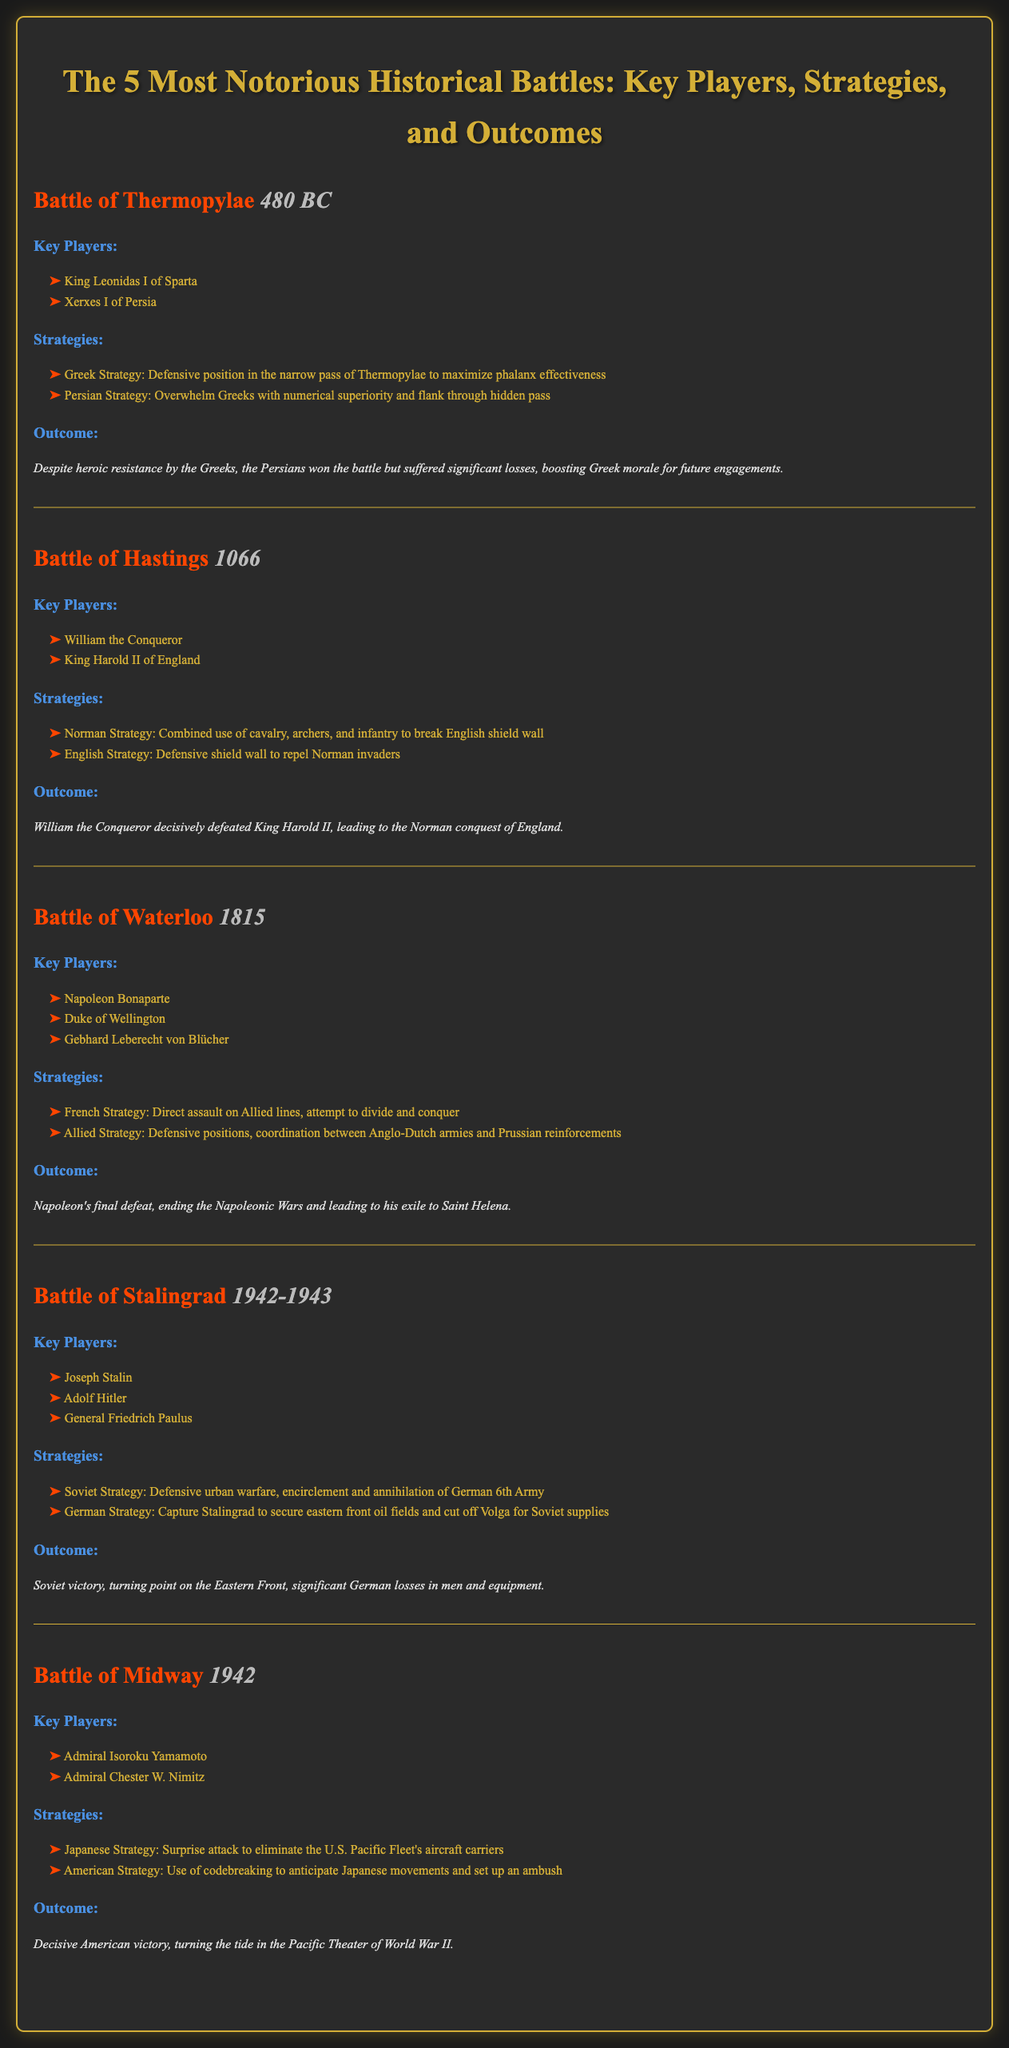What year did the Battle of Thermopylae take place? The year of the Battle of Thermopylae is explicitly stated in the document.
Answer: 480 BC Who were the key players in the Battle of Hastings? The document lists the key players for the Battle of Hastings, highlighting their roles.
Answer: William the Conqueror, King Harold II of England What strategy did the Allied forces use in the Battle of Waterloo? The document explicitly mentions the strategy used by the Allied forces during the Battle of Waterloo.
Answer: Defensive positions, coordination between Anglo-Dutch armies and Prussian reinforcements What was the outcome of the Battle of Stalingrad? The outcome of the Battle of Stalingrad is summarized in the document, providing a clear conclusion of the battle.
Answer: Soviet victory, turning point on the Eastern Front Which battle had Admiral Chester W. Nimitz as a key player? The document identifies battles along with their key players, making it possible to match them.
Answer: Battle of Midway What was the primary objective of the German strategy in the Battle of Stalingrad? The document outlines the German strategy for the Battle of Stalingrad, detailing their primary objective.
Answer: Capture Stalingrad to secure eastern front oil fields How many battles are discussed in this document? The document explicitly presents a list of battles, stating the number at the beginning.
Answer: 5 Which battle marked the end of the Napoleonic Wars? The document specifies the outcome of the Battle of Waterloo, indicating its significance in relation to the Napoleonic Wars.
Answer: Battle of Waterloo What year did the Battle of Midway occur? The document directly provides the year in which the Battle of Midway took place.
Answer: 1942 